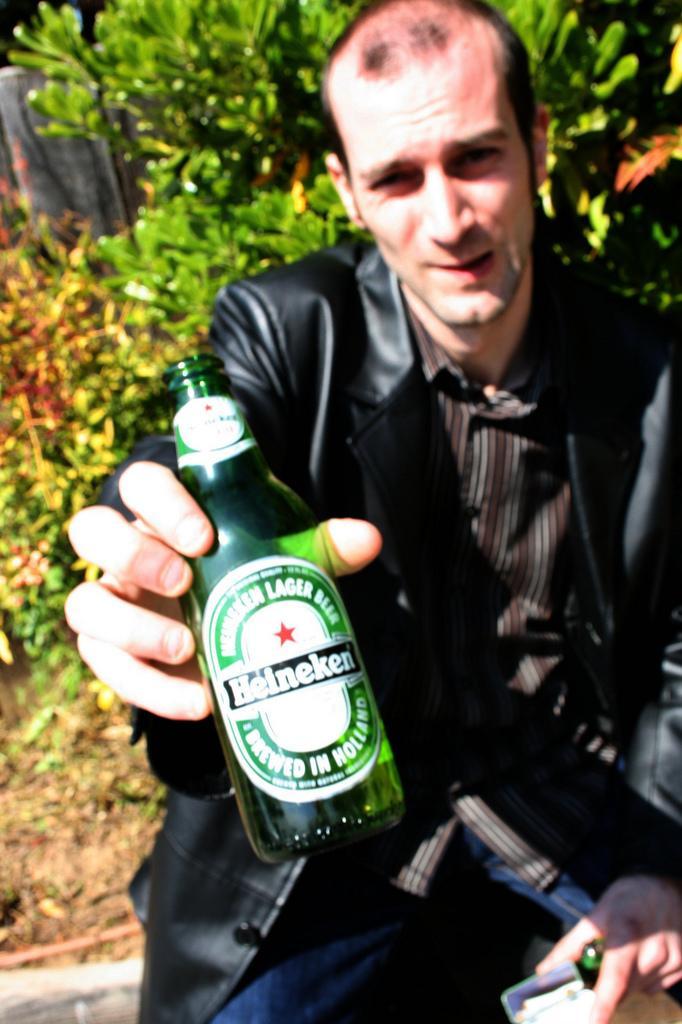Please provide a concise description of this image. As we can see in the image, there is a man holding green color bottle, in the background there are trees. 